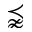Convert formula to latex. <formula><loc_0><loc_0><loc_500><loc_500>\precnapprox</formula> 